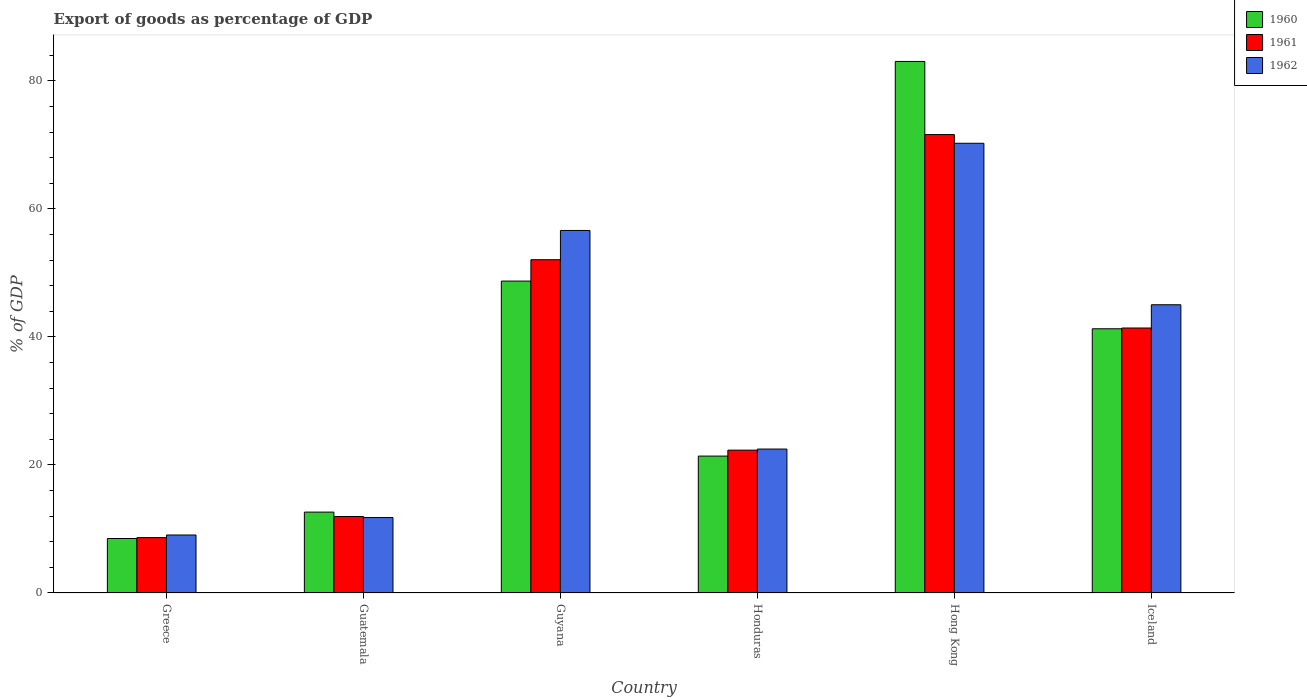How many different coloured bars are there?
Give a very brief answer. 3. Are the number of bars per tick equal to the number of legend labels?
Give a very brief answer. Yes. How many bars are there on the 1st tick from the right?
Your response must be concise. 3. In how many cases, is the number of bars for a given country not equal to the number of legend labels?
Your answer should be compact. 0. What is the export of goods as percentage of GDP in 1962 in Guatemala?
Ensure brevity in your answer.  11.79. Across all countries, what is the maximum export of goods as percentage of GDP in 1961?
Offer a terse response. 71.63. Across all countries, what is the minimum export of goods as percentage of GDP in 1960?
Ensure brevity in your answer.  8.51. In which country was the export of goods as percentage of GDP in 1961 maximum?
Offer a terse response. Hong Kong. What is the total export of goods as percentage of GDP in 1960 in the graph?
Offer a terse response. 215.61. What is the difference between the export of goods as percentage of GDP in 1960 in Guatemala and that in Hong Kong?
Your response must be concise. -70.41. What is the difference between the export of goods as percentage of GDP in 1962 in Guyana and the export of goods as percentage of GDP in 1960 in Hong Kong?
Provide a short and direct response. -26.41. What is the average export of goods as percentage of GDP in 1961 per country?
Offer a very short reply. 34.67. What is the difference between the export of goods as percentage of GDP of/in 1961 and export of goods as percentage of GDP of/in 1962 in Hong Kong?
Provide a succinct answer. 1.36. In how many countries, is the export of goods as percentage of GDP in 1962 greater than 36 %?
Ensure brevity in your answer.  3. What is the ratio of the export of goods as percentage of GDP in 1961 in Guyana to that in Honduras?
Offer a very short reply. 2.33. What is the difference between the highest and the second highest export of goods as percentage of GDP in 1962?
Give a very brief answer. 11.61. What is the difference between the highest and the lowest export of goods as percentage of GDP in 1961?
Offer a very short reply. 62.97. Is the sum of the export of goods as percentage of GDP in 1962 in Guyana and Iceland greater than the maximum export of goods as percentage of GDP in 1960 across all countries?
Your answer should be compact. Yes. Are all the bars in the graph horizontal?
Provide a succinct answer. No. Does the graph contain grids?
Offer a terse response. No. How are the legend labels stacked?
Ensure brevity in your answer.  Vertical. What is the title of the graph?
Keep it short and to the point. Export of goods as percentage of GDP. What is the label or title of the X-axis?
Ensure brevity in your answer.  Country. What is the label or title of the Y-axis?
Your response must be concise. % of GDP. What is the % of GDP of 1960 in Greece?
Provide a succinct answer. 8.51. What is the % of GDP in 1961 in Greece?
Ensure brevity in your answer.  8.65. What is the % of GDP of 1962 in Greece?
Your response must be concise. 9.06. What is the % of GDP in 1960 in Guatemala?
Your answer should be compact. 12.64. What is the % of GDP in 1961 in Guatemala?
Ensure brevity in your answer.  11.95. What is the % of GDP of 1962 in Guatemala?
Give a very brief answer. 11.79. What is the % of GDP of 1960 in Guyana?
Keep it short and to the point. 48.73. What is the % of GDP of 1961 in Guyana?
Your answer should be very brief. 52.07. What is the % of GDP of 1962 in Guyana?
Make the answer very short. 56.64. What is the % of GDP of 1960 in Honduras?
Provide a short and direct response. 21.39. What is the % of GDP in 1961 in Honduras?
Make the answer very short. 22.32. What is the % of GDP of 1962 in Honduras?
Your response must be concise. 22.49. What is the % of GDP of 1960 in Hong Kong?
Offer a very short reply. 83.05. What is the % of GDP in 1961 in Hong Kong?
Provide a short and direct response. 71.63. What is the % of GDP in 1962 in Hong Kong?
Keep it short and to the point. 70.26. What is the % of GDP in 1960 in Iceland?
Your answer should be compact. 41.28. What is the % of GDP in 1961 in Iceland?
Your answer should be compact. 41.4. What is the % of GDP of 1962 in Iceland?
Offer a terse response. 45.03. Across all countries, what is the maximum % of GDP of 1960?
Provide a short and direct response. 83.05. Across all countries, what is the maximum % of GDP of 1961?
Your answer should be compact. 71.63. Across all countries, what is the maximum % of GDP in 1962?
Your answer should be compact. 70.26. Across all countries, what is the minimum % of GDP in 1960?
Provide a short and direct response. 8.51. Across all countries, what is the minimum % of GDP in 1961?
Your answer should be compact. 8.65. Across all countries, what is the minimum % of GDP of 1962?
Your answer should be very brief. 9.06. What is the total % of GDP of 1960 in the graph?
Provide a succinct answer. 215.61. What is the total % of GDP in 1961 in the graph?
Provide a short and direct response. 208.03. What is the total % of GDP of 1962 in the graph?
Keep it short and to the point. 215.28. What is the difference between the % of GDP of 1960 in Greece and that in Guatemala?
Give a very brief answer. -4.13. What is the difference between the % of GDP in 1961 in Greece and that in Guatemala?
Offer a very short reply. -3.3. What is the difference between the % of GDP in 1962 in Greece and that in Guatemala?
Keep it short and to the point. -2.72. What is the difference between the % of GDP of 1960 in Greece and that in Guyana?
Give a very brief answer. -40.22. What is the difference between the % of GDP of 1961 in Greece and that in Guyana?
Provide a short and direct response. -43.42. What is the difference between the % of GDP of 1962 in Greece and that in Guyana?
Your answer should be compact. -47.58. What is the difference between the % of GDP in 1960 in Greece and that in Honduras?
Your answer should be compact. -12.88. What is the difference between the % of GDP in 1961 in Greece and that in Honduras?
Provide a succinct answer. -13.66. What is the difference between the % of GDP in 1962 in Greece and that in Honduras?
Ensure brevity in your answer.  -13.43. What is the difference between the % of GDP of 1960 in Greece and that in Hong Kong?
Your response must be concise. -74.54. What is the difference between the % of GDP in 1961 in Greece and that in Hong Kong?
Provide a short and direct response. -62.97. What is the difference between the % of GDP in 1962 in Greece and that in Hong Kong?
Provide a succinct answer. -61.2. What is the difference between the % of GDP in 1960 in Greece and that in Iceland?
Give a very brief answer. -32.77. What is the difference between the % of GDP of 1961 in Greece and that in Iceland?
Keep it short and to the point. -32.75. What is the difference between the % of GDP in 1962 in Greece and that in Iceland?
Your response must be concise. -35.97. What is the difference between the % of GDP of 1960 in Guatemala and that in Guyana?
Your response must be concise. -36.09. What is the difference between the % of GDP in 1961 in Guatemala and that in Guyana?
Make the answer very short. -40.12. What is the difference between the % of GDP in 1962 in Guatemala and that in Guyana?
Keep it short and to the point. -44.86. What is the difference between the % of GDP in 1960 in Guatemala and that in Honduras?
Your answer should be very brief. -8.75. What is the difference between the % of GDP in 1961 in Guatemala and that in Honduras?
Your answer should be very brief. -10.37. What is the difference between the % of GDP of 1962 in Guatemala and that in Honduras?
Your answer should be very brief. -10.7. What is the difference between the % of GDP in 1960 in Guatemala and that in Hong Kong?
Give a very brief answer. -70.41. What is the difference between the % of GDP in 1961 in Guatemala and that in Hong Kong?
Offer a very short reply. -59.67. What is the difference between the % of GDP of 1962 in Guatemala and that in Hong Kong?
Make the answer very short. -58.48. What is the difference between the % of GDP in 1960 in Guatemala and that in Iceland?
Your answer should be compact. -28.64. What is the difference between the % of GDP of 1961 in Guatemala and that in Iceland?
Your answer should be very brief. -29.45. What is the difference between the % of GDP in 1962 in Guatemala and that in Iceland?
Provide a short and direct response. -33.25. What is the difference between the % of GDP of 1960 in Guyana and that in Honduras?
Provide a short and direct response. 27.34. What is the difference between the % of GDP of 1961 in Guyana and that in Honduras?
Offer a terse response. 29.75. What is the difference between the % of GDP in 1962 in Guyana and that in Honduras?
Make the answer very short. 34.15. What is the difference between the % of GDP in 1960 in Guyana and that in Hong Kong?
Provide a short and direct response. -34.32. What is the difference between the % of GDP of 1961 in Guyana and that in Hong Kong?
Offer a terse response. -19.55. What is the difference between the % of GDP in 1962 in Guyana and that in Hong Kong?
Provide a succinct answer. -13.62. What is the difference between the % of GDP of 1960 in Guyana and that in Iceland?
Provide a succinct answer. 7.45. What is the difference between the % of GDP in 1961 in Guyana and that in Iceland?
Provide a succinct answer. 10.67. What is the difference between the % of GDP of 1962 in Guyana and that in Iceland?
Your response must be concise. 11.61. What is the difference between the % of GDP in 1960 in Honduras and that in Hong Kong?
Provide a short and direct response. -61.66. What is the difference between the % of GDP in 1961 in Honduras and that in Hong Kong?
Your answer should be compact. -49.31. What is the difference between the % of GDP in 1962 in Honduras and that in Hong Kong?
Make the answer very short. -47.78. What is the difference between the % of GDP of 1960 in Honduras and that in Iceland?
Your answer should be very brief. -19.89. What is the difference between the % of GDP of 1961 in Honduras and that in Iceland?
Make the answer very short. -19.08. What is the difference between the % of GDP of 1962 in Honduras and that in Iceland?
Offer a very short reply. -22.55. What is the difference between the % of GDP of 1960 in Hong Kong and that in Iceland?
Offer a terse response. 41.77. What is the difference between the % of GDP in 1961 in Hong Kong and that in Iceland?
Make the answer very short. 30.22. What is the difference between the % of GDP in 1962 in Hong Kong and that in Iceland?
Offer a very short reply. 25.23. What is the difference between the % of GDP in 1960 in Greece and the % of GDP in 1961 in Guatemala?
Provide a succinct answer. -3.44. What is the difference between the % of GDP of 1960 in Greece and the % of GDP of 1962 in Guatemala?
Offer a terse response. -3.28. What is the difference between the % of GDP in 1961 in Greece and the % of GDP in 1962 in Guatemala?
Provide a succinct answer. -3.13. What is the difference between the % of GDP of 1960 in Greece and the % of GDP of 1961 in Guyana?
Provide a short and direct response. -43.56. What is the difference between the % of GDP in 1960 in Greece and the % of GDP in 1962 in Guyana?
Provide a short and direct response. -48.13. What is the difference between the % of GDP of 1961 in Greece and the % of GDP of 1962 in Guyana?
Provide a succinct answer. -47.99. What is the difference between the % of GDP of 1960 in Greece and the % of GDP of 1961 in Honduras?
Offer a very short reply. -13.81. What is the difference between the % of GDP of 1960 in Greece and the % of GDP of 1962 in Honduras?
Offer a terse response. -13.98. What is the difference between the % of GDP in 1961 in Greece and the % of GDP in 1962 in Honduras?
Your answer should be very brief. -13.83. What is the difference between the % of GDP of 1960 in Greece and the % of GDP of 1961 in Hong Kong?
Ensure brevity in your answer.  -63.11. What is the difference between the % of GDP of 1960 in Greece and the % of GDP of 1962 in Hong Kong?
Make the answer very short. -61.75. What is the difference between the % of GDP of 1961 in Greece and the % of GDP of 1962 in Hong Kong?
Your response must be concise. -61.61. What is the difference between the % of GDP of 1960 in Greece and the % of GDP of 1961 in Iceland?
Your answer should be very brief. -32.89. What is the difference between the % of GDP in 1960 in Greece and the % of GDP in 1962 in Iceland?
Provide a succinct answer. -36.52. What is the difference between the % of GDP in 1961 in Greece and the % of GDP in 1962 in Iceland?
Ensure brevity in your answer.  -36.38. What is the difference between the % of GDP of 1960 in Guatemala and the % of GDP of 1961 in Guyana?
Your response must be concise. -39.43. What is the difference between the % of GDP of 1960 in Guatemala and the % of GDP of 1962 in Guyana?
Give a very brief answer. -44. What is the difference between the % of GDP in 1961 in Guatemala and the % of GDP in 1962 in Guyana?
Ensure brevity in your answer.  -44.69. What is the difference between the % of GDP in 1960 in Guatemala and the % of GDP in 1961 in Honduras?
Keep it short and to the point. -9.68. What is the difference between the % of GDP of 1960 in Guatemala and the % of GDP of 1962 in Honduras?
Your answer should be very brief. -9.85. What is the difference between the % of GDP of 1961 in Guatemala and the % of GDP of 1962 in Honduras?
Your answer should be compact. -10.54. What is the difference between the % of GDP in 1960 in Guatemala and the % of GDP in 1961 in Hong Kong?
Keep it short and to the point. -58.99. What is the difference between the % of GDP in 1960 in Guatemala and the % of GDP in 1962 in Hong Kong?
Provide a succinct answer. -57.63. What is the difference between the % of GDP of 1961 in Guatemala and the % of GDP of 1962 in Hong Kong?
Offer a very short reply. -58.31. What is the difference between the % of GDP in 1960 in Guatemala and the % of GDP in 1961 in Iceland?
Provide a short and direct response. -28.76. What is the difference between the % of GDP of 1960 in Guatemala and the % of GDP of 1962 in Iceland?
Offer a terse response. -32.4. What is the difference between the % of GDP of 1961 in Guatemala and the % of GDP of 1962 in Iceland?
Keep it short and to the point. -33.08. What is the difference between the % of GDP of 1960 in Guyana and the % of GDP of 1961 in Honduras?
Give a very brief answer. 26.41. What is the difference between the % of GDP of 1960 in Guyana and the % of GDP of 1962 in Honduras?
Your answer should be very brief. 26.24. What is the difference between the % of GDP of 1961 in Guyana and the % of GDP of 1962 in Honduras?
Give a very brief answer. 29.58. What is the difference between the % of GDP of 1960 in Guyana and the % of GDP of 1961 in Hong Kong?
Your answer should be compact. -22.89. What is the difference between the % of GDP in 1960 in Guyana and the % of GDP in 1962 in Hong Kong?
Your answer should be very brief. -21.53. What is the difference between the % of GDP of 1961 in Guyana and the % of GDP of 1962 in Hong Kong?
Ensure brevity in your answer.  -18.19. What is the difference between the % of GDP in 1960 in Guyana and the % of GDP in 1961 in Iceland?
Offer a terse response. 7.33. What is the difference between the % of GDP of 1960 in Guyana and the % of GDP of 1962 in Iceland?
Provide a succinct answer. 3.7. What is the difference between the % of GDP of 1961 in Guyana and the % of GDP of 1962 in Iceland?
Keep it short and to the point. 7.04. What is the difference between the % of GDP in 1960 in Honduras and the % of GDP in 1961 in Hong Kong?
Provide a succinct answer. -50.23. What is the difference between the % of GDP of 1960 in Honduras and the % of GDP of 1962 in Hong Kong?
Provide a short and direct response. -48.87. What is the difference between the % of GDP of 1961 in Honduras and the % of GDP of 1962 in Hong Kong?
Offer a very short reply. -47.95. What is the difference between the % of GDP of 1960 in Honduras and the % of GDP of 1961 in Iceland?
Make the answer very short. -20.01. What is the difference between the % of GDP of 1960 in Honduras and the % of GDP of 1962 in Iceland?
Provide a succinct answer. -23.64. What is the difference between the % of GDP of 1961 in Honduras and the % of GDP of 1962 in Iceland?
Give a very brief answer. -22.72. What is the difference between the % of GDP of 1960 in Hong Kong and the % of GDP of 1961 in Iceland?
Ensure brevity in your answer.  41.65. What is the difference between the % of GDP in 1960 in Hong Kong and the % of GDP in 1962 in Iceland?
Give a very brief answer. 38.01. What is the difference between the % of GDP in 1961 in Hong Kong and the % of GDP in 1962 in Iceland?
Keep it short and to the point. 26.59. What is the average % of GDP of 1960 per country?
Your answer should be compact. 35.93. What is the average % of GDP in 1961 per country?
Provide a short and direct response. 34.67. What is the average % of GDP in 1962 per country?
Ensure brevity in your answer.  35.88. What is the difference between the % of GDP of 1960 and % of GDP of 1961 in Greece?
Ensure brevity in your answer.  -0.14. What is the difference between the % of GDP of 1960 and % of GDP of 1962 in Greece?
Provide a short and direct response. -0.55. What is the difference between the % of GDP of 1961 and % of GDP of 1962 in Greece?
Keep it short and to the point. -0.41. What is the difference between the % of GDP in 1960 and % of GDP in 1961 in Guatemala?
Ensure brevity in your answer.  0.69. What is the difference between the % of GDP of 1960 and % of GDP of 1962 in Guatemala?
Keep it short and to the point. 0.85. What is the difference between the % of GDP of 1961 and % of GDP of 1962 in Guatemala?
Provide a short and direct response. 0.17. What is the difference between the % of GDP of 1960 and % of GDP of 1961 in Guyana?
Provide a short and direct response. -3.34. What is the difference between the % of GDP in 1960 and % of GDP in 1962 in Guyana?
Give a very brief answer. -7.91. What is the difference between the % of GDP in 1961 and % of GDP in 1962 in Guyana?
Offer a very short reply. -4.57. What is the difference between the % of GDP of 1960 and % of GDP of 1961 in Honduras?
Give a very brief answer. -0.93. What is the difference between the % of GDP of 1960 and % of GDP of 1962 in Honduras?
Ensure brevity in your answer.  -1.1. What is the difference between the % of GDP in 1961 and % of GDP in 1962 in Honduras?
Your answer should be very brief. -0.17. What is the difference between the % of GDP of 1960 and % of GDP of 1961 in Hong Kong?
Provide a short and direct response. 11.42. What is the difference between the % of GDP in 1960 and % of GDP in 1962 in Hong Kong?
Keep it short and to the point. 12.78. What is the difference between the % of GDP of 1961 and % of GDP of 1962 in Hong Kong?
Keep it short and to the point. 1.36. What is the difference between the % of GDP of 1960 and % of GDP of 1961 in Iceland?
Your response must be concise. -0.12. What is the difference between the % of GDP of 1960 and % of GDP of 1962 in Iceland?
Give a very brief answer. -3.75. What is the difference between the % of GDP in 1961 and % of GDP in 1962 in Iceland?
Keep it short and to the point. -3.63. What is the ratio of the % of GDP of 1960 in Greece to that in Guatemala?
Your response must be concise. 0.67. What is the ratio of the % of GDP of 1961 in Greece to that in Guatemala?
Your answer should be compact. 0.72. What is the ratio of the % of GDP of 1962 in Greece to that in Guatemala?
Make the answer very short. 0.77. What is the ratio of the % of GDP of 1960 in Greece to that in Guyana?
Keep it short and to the point. 0.17. What is the ratio of the % of GDP of 1961 in Greece to that in Guyana?
Keep it short and to the point. 0.17. What is the ratio of the % of GDP in 1962 in Greece to that in Guyana?
Your answer should be compact. 0.16. What is the ratio of the % of GDP in 1960 in Greece to that in Honduras?
Provide a succinct answer. 0.4. What is the ratio of the % of GDP in 1961 in Greece to that in Honduras?
Ensure brevity in your answer.  0.39. What is the ratio of the % of GDP of 1962 in Greece to that in Honduras?
Your answer should be compact. 0.4. What is the ratio of the % of GDP in 1960 in Greece to that in Hong Kong?
Make the answer very short. 0.1. What is the ratio of the % of GDP in 1961 in Greece to that in Hong Kong?
Your response must be concise. 0.12. What is the ratio of the % of GDP of 1962 in Greece to that in Hong Kong?
Offer a terse response. 0.13. What is the ratio of the % of GDP of 1960 in Greece to that in Iceland?
Make the answer very short. 0.21. What is the ratio of the % of GDP in 1961 in Greece to that in Iceland?
Your answer should be very brief. 0.21. What is the ratio of the % of GDP in 1962 in Greece to that in Iceland?
Give a very brief answer. 0.2. What is the ratio of the % of GDP in 1960 in Guatemala to that in Guyana?
Your response must be concise. 0.26. What is the ratio of the % of GDP in 1961 in Guatemala to that in Guyana?
Offer a terse response. 0.23. What is the ratio of the % of GDP of 1962 in Guatemala to that in Guyana?
Provide a short and direct response. 0.21. What is the ratio of the % of GDP of 1960 in Guatemala to that in Honduras?
Keep it short and to the point. 0.59. What is the ratio of the % of GDP in 1961 in Guatemala to that in Honduras?
Provide a short and direct response. 0.54. What is the ratio of the % of GDP of 1962 in Guatemala to that in Honduras?
Make the answer very short. 0.52. What is the ratio of the % of GDP of 1960 in Guatemala to that in Hong Kong?
Ensure brevity in your answer.  0.15. What is the ratio of the % of GDP in 1961 in Guatemala to that in Hong Kong?
Offer a terse response. 0.17. What is the ratio of the % of GDP of 1962 in Guatemala to that in Hong Kong?
Your answer should be compact. 0.17. What is the ratio of the % of GDP in 1960 in Guatemala to that in Iceland?
Give a very brief answer. 0.31. What is the ratio of the % of GDP in 1961 in Guatemala to that in Iceland?
Provide a short and direct response. 0.29. What is the ratio of the % of GDP in 1962 in Guatemala to that in Iceland?
Give a very brief answer. 0.26. What is the ratio of the % of GDP in 1960 in Guyana to that in Honduras?
Your answer should be compact. 2.28. What is the ratio of the % of GDP of 1961 in Guyana to that in Honduras?
Keep it short and to the point. 2.33. What is the ratio of the % of GDP of 1962 in Guyana to that in Honduras?
Offer a very short reply. 2.52. What is the ratio of the % of GDP in 1960 in Guyana to that in Hong Kong?
Offer a terse response. 0.59. What is the ratio of the % of GDP in 1961 in Guyana to that in Hong Kong?
Provide a short and direct response. 0.73. What is the ratio of the % of GDP in 1962 in Guyana to that in Hong Kong?
Keep it short and to the point. 0.81. What is the ratio of the % of GDP of 1960 in Guyana to that in Iceland?
Ensure brevity in your answer.  1.18. What is the ratio of the % of GDP of 1961 in Guyana to that in Iceland?
Offer a very short reply. 1.26. What is the ratio of the % of GDP of 1962 in Guyana to that in Iceland?
Make the answer very short. 1.26. What is the ratio of the % of GDP in 1960 in Honduras to that in Hong Kong?
Ensure brevity in your answer.  0.26. What is the ratio of the % of GDP of 1961 in Honduras to that in Hong Kong?
Your answer should be compact. 0.31. What is the ratio of the % of GDP of 1962 in Honduras to that in Hong Kong?
Your answer should be very brief. 0.32. What is the ratio of the % of GDP in 1960 in Honduras to that in Iceland?
Provide a succinct answer. 0.52. What is the ratio of the % of GDP in 1961 in Honduras to that in Iceland?
Offer a terse response. 0.54. What is the ratio of the % of GDP in 1962 in Honduras to that in Iceland?
Your answer should be very brief. 0.5. What is the ratio of the % of GDP of 1960 in Hong Kong to that in Iceland?
Provide a succinct answer. 2.01. What is the ratio of the % of GDP in 1961 in Hong Kong to that in Iceland?
Give a very brief answer. 1.73. What is the ratio of the % of GDP of 1962 in Hong Kong to that in Iceland?
Your answer should be very brief. 1.56. What is the difference between the highest and the second highest % of GDP in 1960?
Your answer should be very brief. 34.32. What is the difference between the highest and the second highest % of GDP of 1961?
Ensure brevity in your answer.  19.55. What is the difference between the highest and the second highest % of GDP in 1962?
Make the answer very short. 13.62. What is the difference between the highest and the lowest % of GDP in 1960?
Your response must be concise. 74.54. What is the difference between the highest and the lowest % of GDP of 1961?
Provide a succinct answer. 62.97. What is the difference between the highest and the lowest % of GDP in 1962?
Provide a succinct answer. 61.2. 